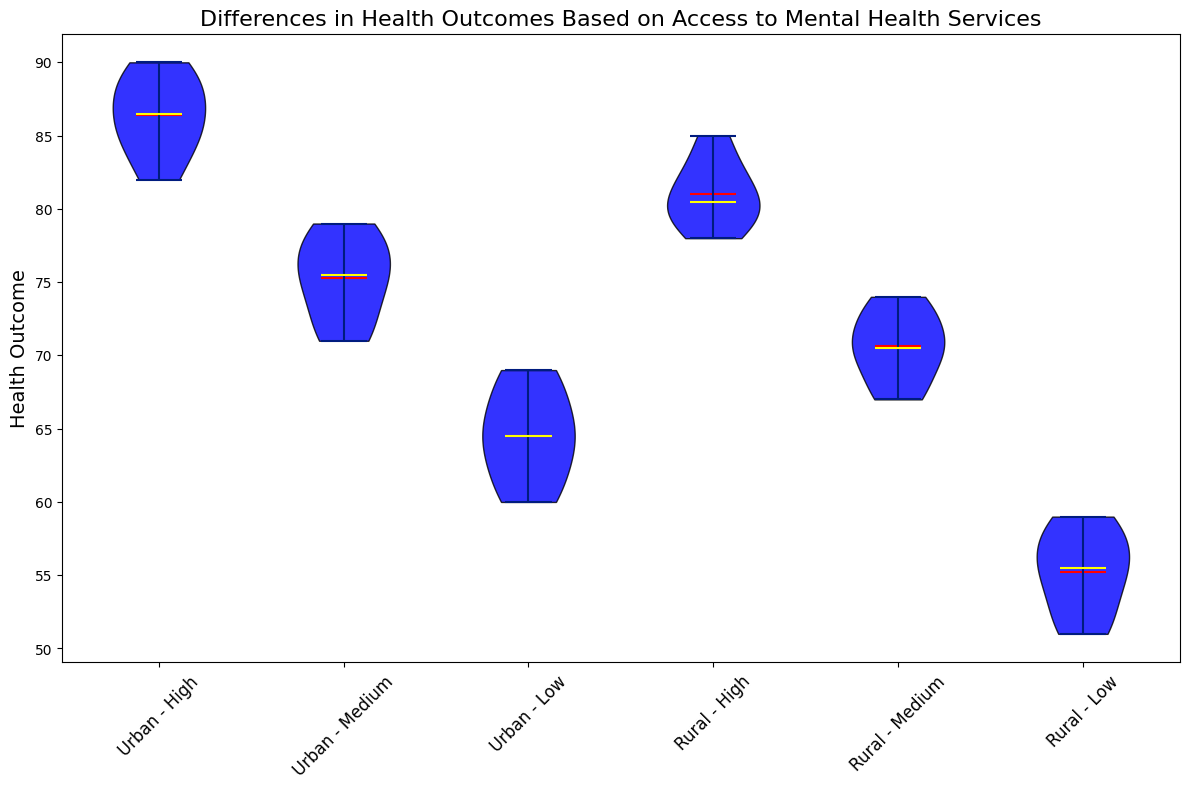Which group has the highest median health outcome? Look at the yellow line that represents the median value for each group. The group "Urban - High" has the highest median value.
Answer: Urban - High Which group has the lowest mean health outcome? Observe the red line that indicates the mean value for each group. The group "Rural - Low" has the lowest mean value.
Answer: Rural - Low What's the average difference in median health outcomes between "Urban - High" and "Rural - Low"? First, find the median health outcome for both "Urban - High" and "Rural - Low" groups by looking at the yellow lines. Calculate the absolute difference between these medians and then average that value if required. For simplicity, taking the direct difference is (Urban - High: 86 - Rural - Low: 54) = 32.
Answer: 32 In which location (Urban or Rural) does a High level of access to mental health services result in a higher median health outcome? Compare the yellow lines for "High" access levels in both Urban and Rural locations. The "Urban - High" group has a higher median health outcome than "Rural - High".
Answer: Urban How does the spread of health outcomes in "Urban - Low" compare to "Rural - Low"? Compare the width and range of the blue bodies representing both "Urban - Low" and "Rural - Low" groups. The spread (interquartile range) in "Urban - Low" is visually narrower than in "Rural - Low", indicating less variability.
Answer: Narrower in Urban - Low Which group shows the largest range of health outcomes? Look at the span of the blue bodies from minimum to maximum values. The "Rural - Low" group has the largest range.
Answer: Rural - Low Do Urban areas generally have better health outcomes than Rural areas given the same access level? Compare the average positions of medians and means (yellow and red lines) of each access level between Urban and Rural. For all levels (High, Medium, Low), Urban generally shows better health outcomes as indicated by higher median and mean values.
Answer: Yes What is the difference between the mean health outcomes of "Urban - Medium" and "Rural - Medium"? Locate the red lines that represent the mean values for both "Urban - Medium" and "Rural - Medium". Subtract the mean value of "Rural - Medium" from "Urban - Medium".
Answer: Urban - Medium mean is higher by 4 points 